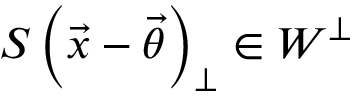Convert formula to latex. <formula><loc_0><loc_0><loc_500><loc_500>S \left ( \vec { x } - \vec { \theta } \right ) _ { \perp } \in W ^ { \perp }</formula> 